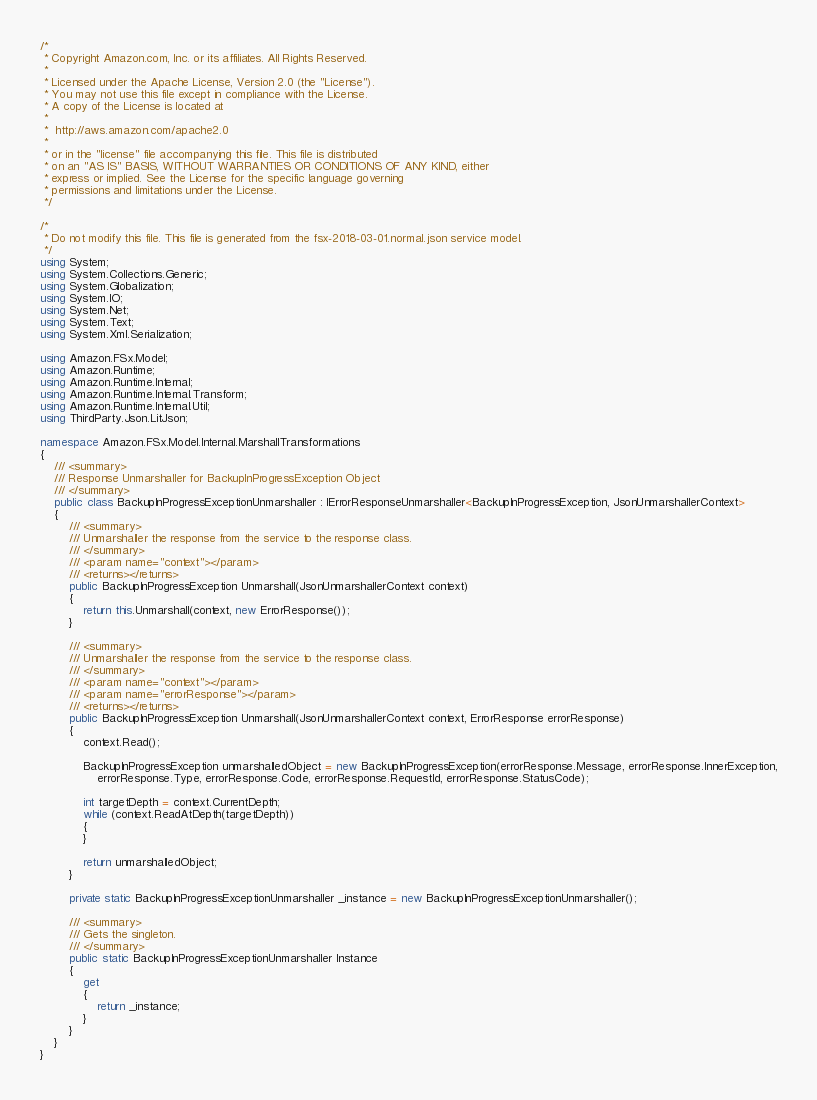Convert code to text. <code><loc_0><loc_0><loc_500><loc_500><_C#_>/*
 * Copyright Amazon.com, Inc. or its affiliates. All Rights Reserved.
 * 
 * Licensed under the Apache License, Version 2.0 (the "License").
 * You may not use this file except in compliance with the License.
 * A copy of the License is located at
 * 
 *  http://aws.amazon.com/apache2.0
 * 
 * or in the "license" file accompanying this file. This file is distributed
 * on an "AS IS" BASIS, WITHOUT WARRANTIES OR CONDITIONS OF ANY KIND, either
 * express or implied. See the License for the specific language governing
 * permissions and limitations under the License.
 */

/*
 * Do not modify this file. This file is generated from the fsx-2018-03-01.normal.json service model.
 */
using System;
using System.Collections.Generic;
using System.Globalization;
using System.IO;
using System.Net;
using System.Text;
using System.Xml.Serialization;

using Amazon.FSx.Model;
using Amazon.Runtime;
using Amazon.Runtime.Internal;
using Amazon.Runtime.Internal.Transform;
using Amazon.Runtime.Internal.Util;
using ThirdParty.Json.LitJson;

namespace Amazon.FSx.Model.Internal.MarshallTransformations
{
    /// <summary>
    /// Response Unmarshaller for BackupInProgressException Object
    /// </summary>  
    public class BackupInProgressExceptionUnmarshaller : IErrorResponseUnmarshaller<BackupInProgressException, JsonUnmarshallerContext>
    {
        /// <summary>
        /// Unmarshaller the response from the service to the response class.
        /// </summary>  
        /// <param name="context"></param>
        /// <returns></returns>
        public BackupInProgressException Unmarshall(JsonUnmarshallerContext context)
        {
            return this.Unmarshall(context, new ErrorResponse());
        }

        /// <summary>
        /// Unmarshaller the response from the service to the response class.
        /// </summary>  
        /// <param name="context"></param>
        /// <param name="errorResponse"></param>
        /// <returns></returns>
        public BackupInProgressException Unmarshall(JsonUnmarshallerContext context, ErrorResponse errorResponse)
        {
            context.Read();

            BackupInProgressException unmarshalledObject = new BackupInProgressException(errorResponse.Message, errorResponse.InnerException,
                errorResponse.Type, errorResponse.Code, errorResponse.RequestId, errorResponse.StatusCode);
        
            int targetDepth = context.CurrentDepth;
            while (context.ReadAtDepth(targetDepth))
            {
            }
          
            return unmarshalledObject;
        }

        private static BackupInProgressExceptionUnmarshaller _instance = new BackupInProgressExceptionUnmarshaller();        

        /// <summary>
        /// Gets the singleton.
        /// </summary>  
        public static BackupInProgressExceptionUnmarshaller Instance
        {
            get
            {
                return _instance;
            }
        }
    }
}</code> 